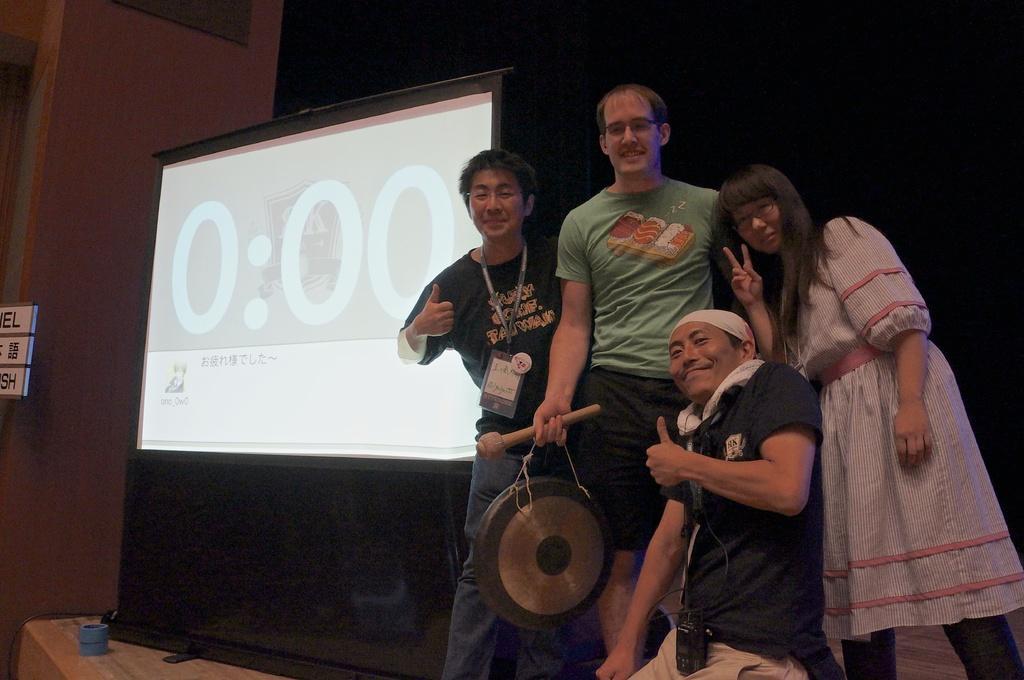Could you give a brief overview of what you see in this image? In this image in the center there are four persons who are standing and one person is sitting, on the right side there is one screen and in the background there is a wall. At the bottom there is one television and table. 